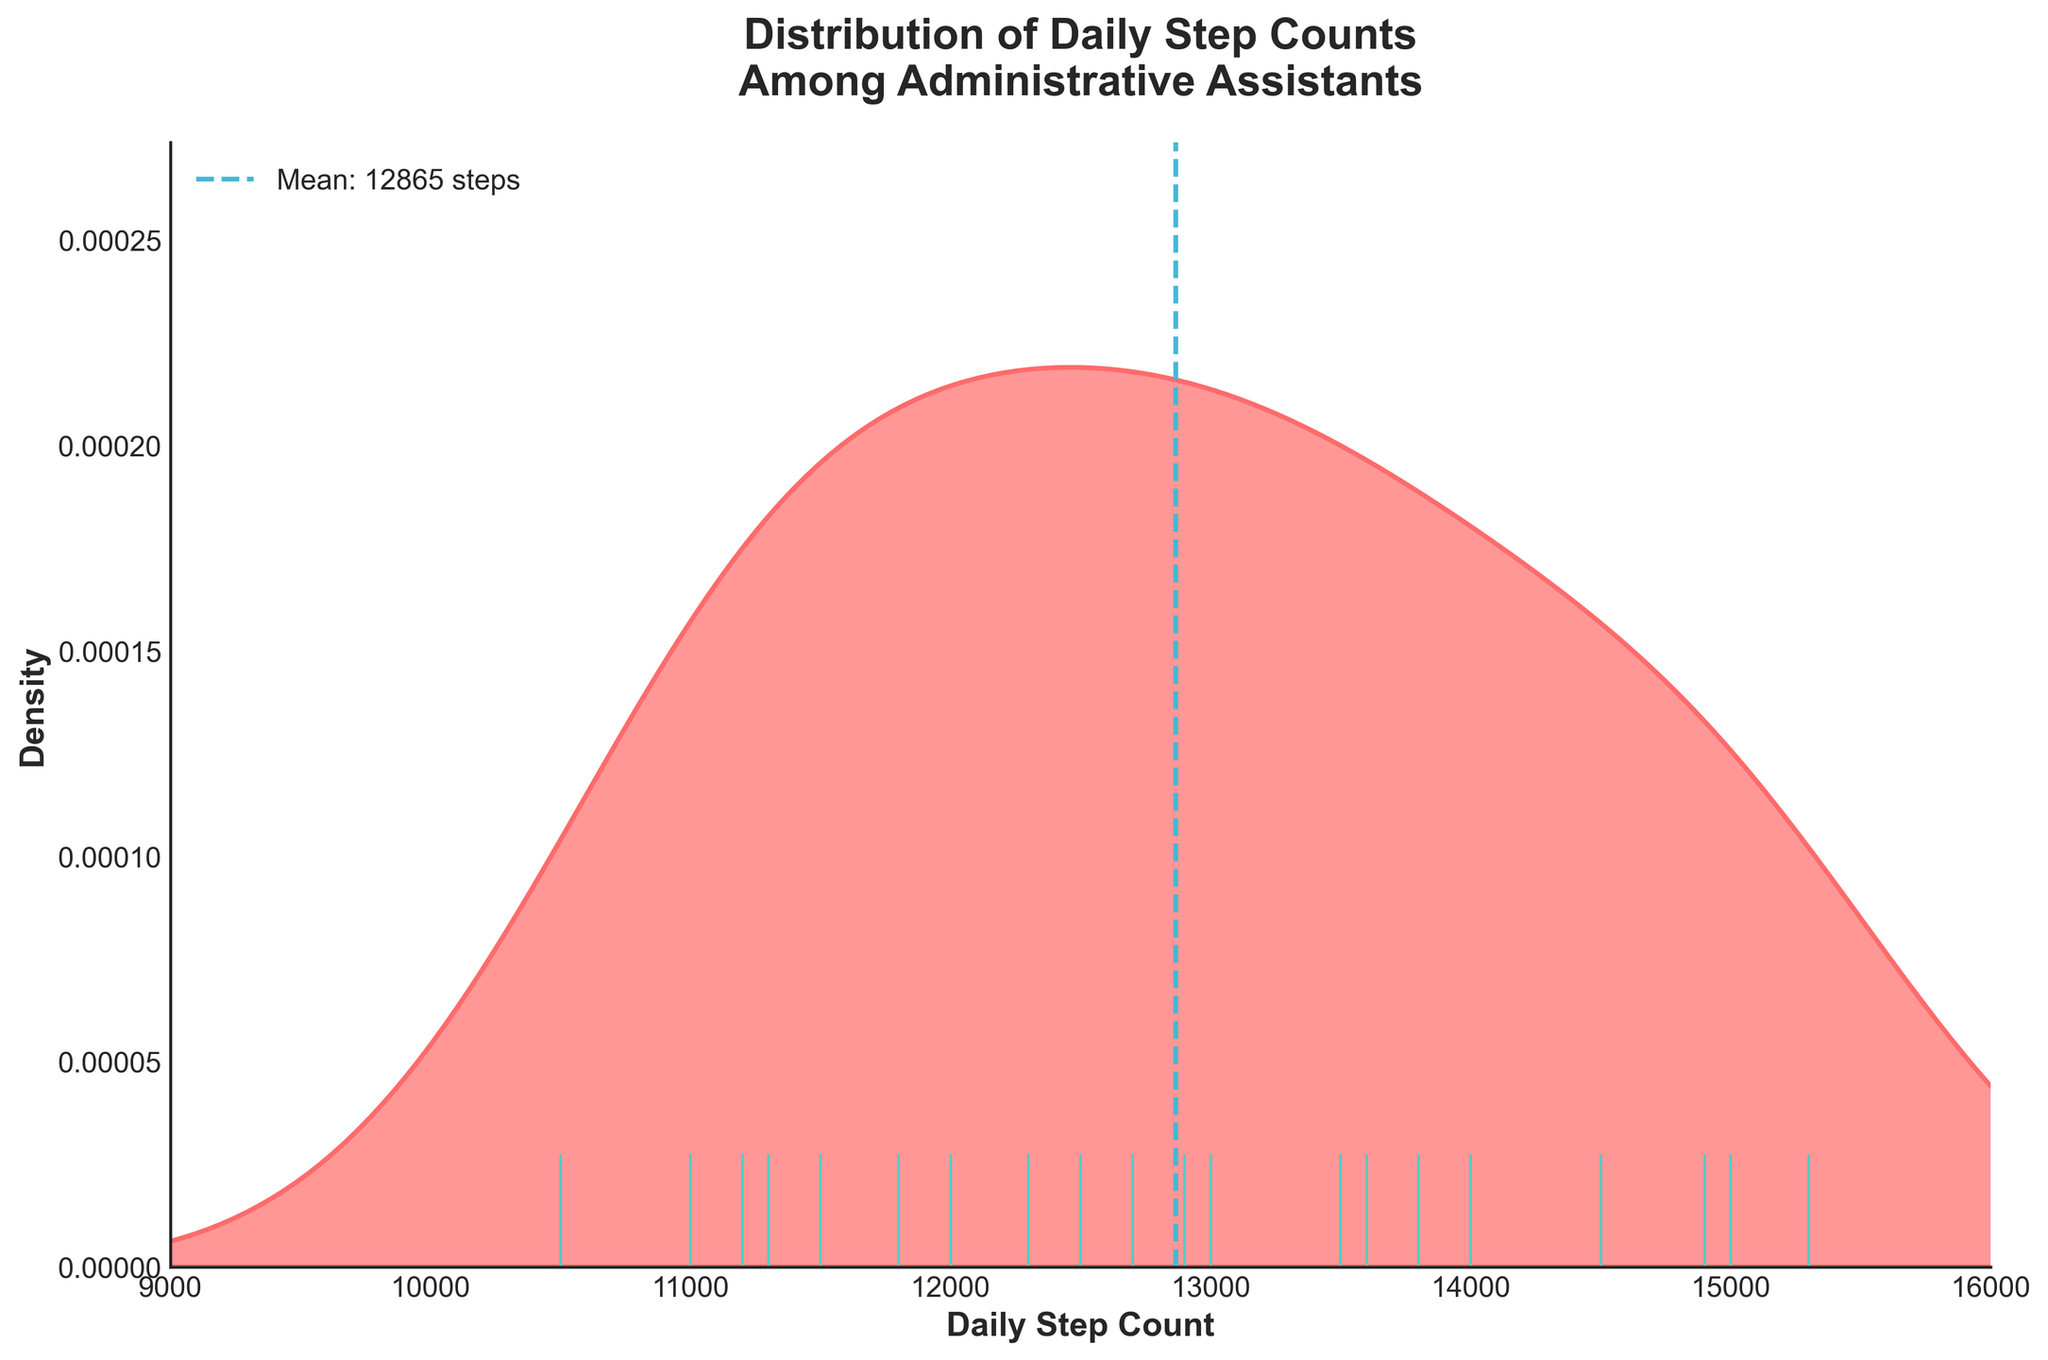What is the mean daily step count shown on the plot? The mean daily step count is indicated by a vertical dashed line in the plot and the label beside it. The label says "Mean: 12960 steps".
Answer: 12960 steps What is the color of the shaded area in the plot? The color of the shaded area is primarily a pinkish-red hue which is used to fill the distribution area. This helps highlight the density of step counts visually.
Answer: Pinkish-red Between what range do most daily step counts lie? The most dense part of the distribution is found by looking at the peak area of the shaded curve. It seems highest between approximately 11,000 and 14,000 steps, representing the most common range for daily step counts.
Answer: 11,000 - 14,000 steps Are there any points where individual step counts are marked? If yes, what color are these marks? Yes, individual step counts are marked by small vertical lines along the x-axis using a different color. These rug plot points are colored turquoise-green.
Answer: Turquoise-green How does the daily step count distribution peak within the dataset? The plot has a noticeable peak indicating high density of step counts around the range of 12,000 to 13,000 steps. This can be observed by the highest point of the shaded area.
Answer: Around 12,000 to 13,000 steps Which interval has more individual step counts marked: 10,000-11,000 or 15,000-16,000? By counting the rugplot marks within each interval, we observe that the interval 10,000-11,000 has more individual step counts marked compared to 15,000-16,000.
Answer: 10,000-11,000 Comparing the employees with a step count around 15,000 steps, which interval does this range mostly lie within? Examining the distribution, the interval around 15,000 steps predominantly falls at the right tail of the distribution, suggesting fewer employees have such high step counts.
Answer: Right tail of the distribution How does the spread of step counts below the mean compare to those above the mean? The spread of step counts below the mean (12,960 steps) appears more concentrated around the central peak, while above the mean, the distribution seems more spread out and covers a wider range.
Answer: Below mean: more concentrated; Above mean: more spread out Based on the visual appearance of the density plot, is the data distribution skewed? By looking at the symmetry of the distribution, it appears slightly skewed to the right, indicating a longer tail on the higher end of step counts.
Answer: Slightly right-skewed What range of daily step counts shows the lowest density according to the plot? The lowest density areas are observed at the boundaries of the plot, specifically below 10,000 and above 15,000 steps, where the shaded area almost tapers off.
Answer: Below 10,000 and above 15,000 steps 